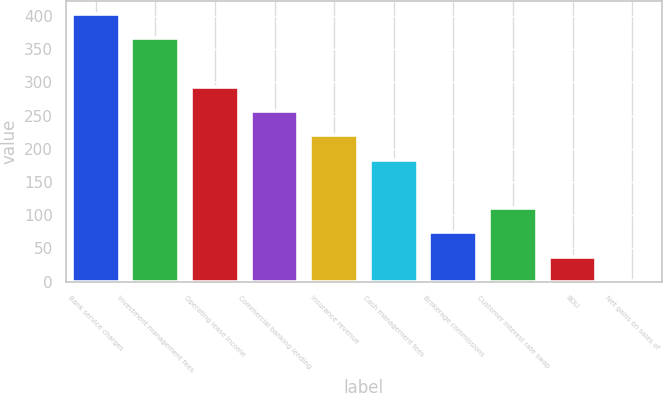Convert chart to OTSL. <chart><loc_0><loc_0><loc_500><loc_500><bar_chart><fcel>Bank service charges<fcel>Investment management fees<fcel>Operating lease income<fcel>Commercial banking lending<fcel>Insurance revenue<fcel>Cash management fees<fcel>Brokerage commissions<fcel>Customer interest rate swap<fcel>BOLI<fcel>Net gains on sales of<nl><fcel>402.92<fcel>366.4<fcel>293.36<fcel>256.84<fcel>220.32<fcel>183.8<fcel>74.24<fcel>110.76<fcel>37.72<fcel>1.2<nl></chart> 